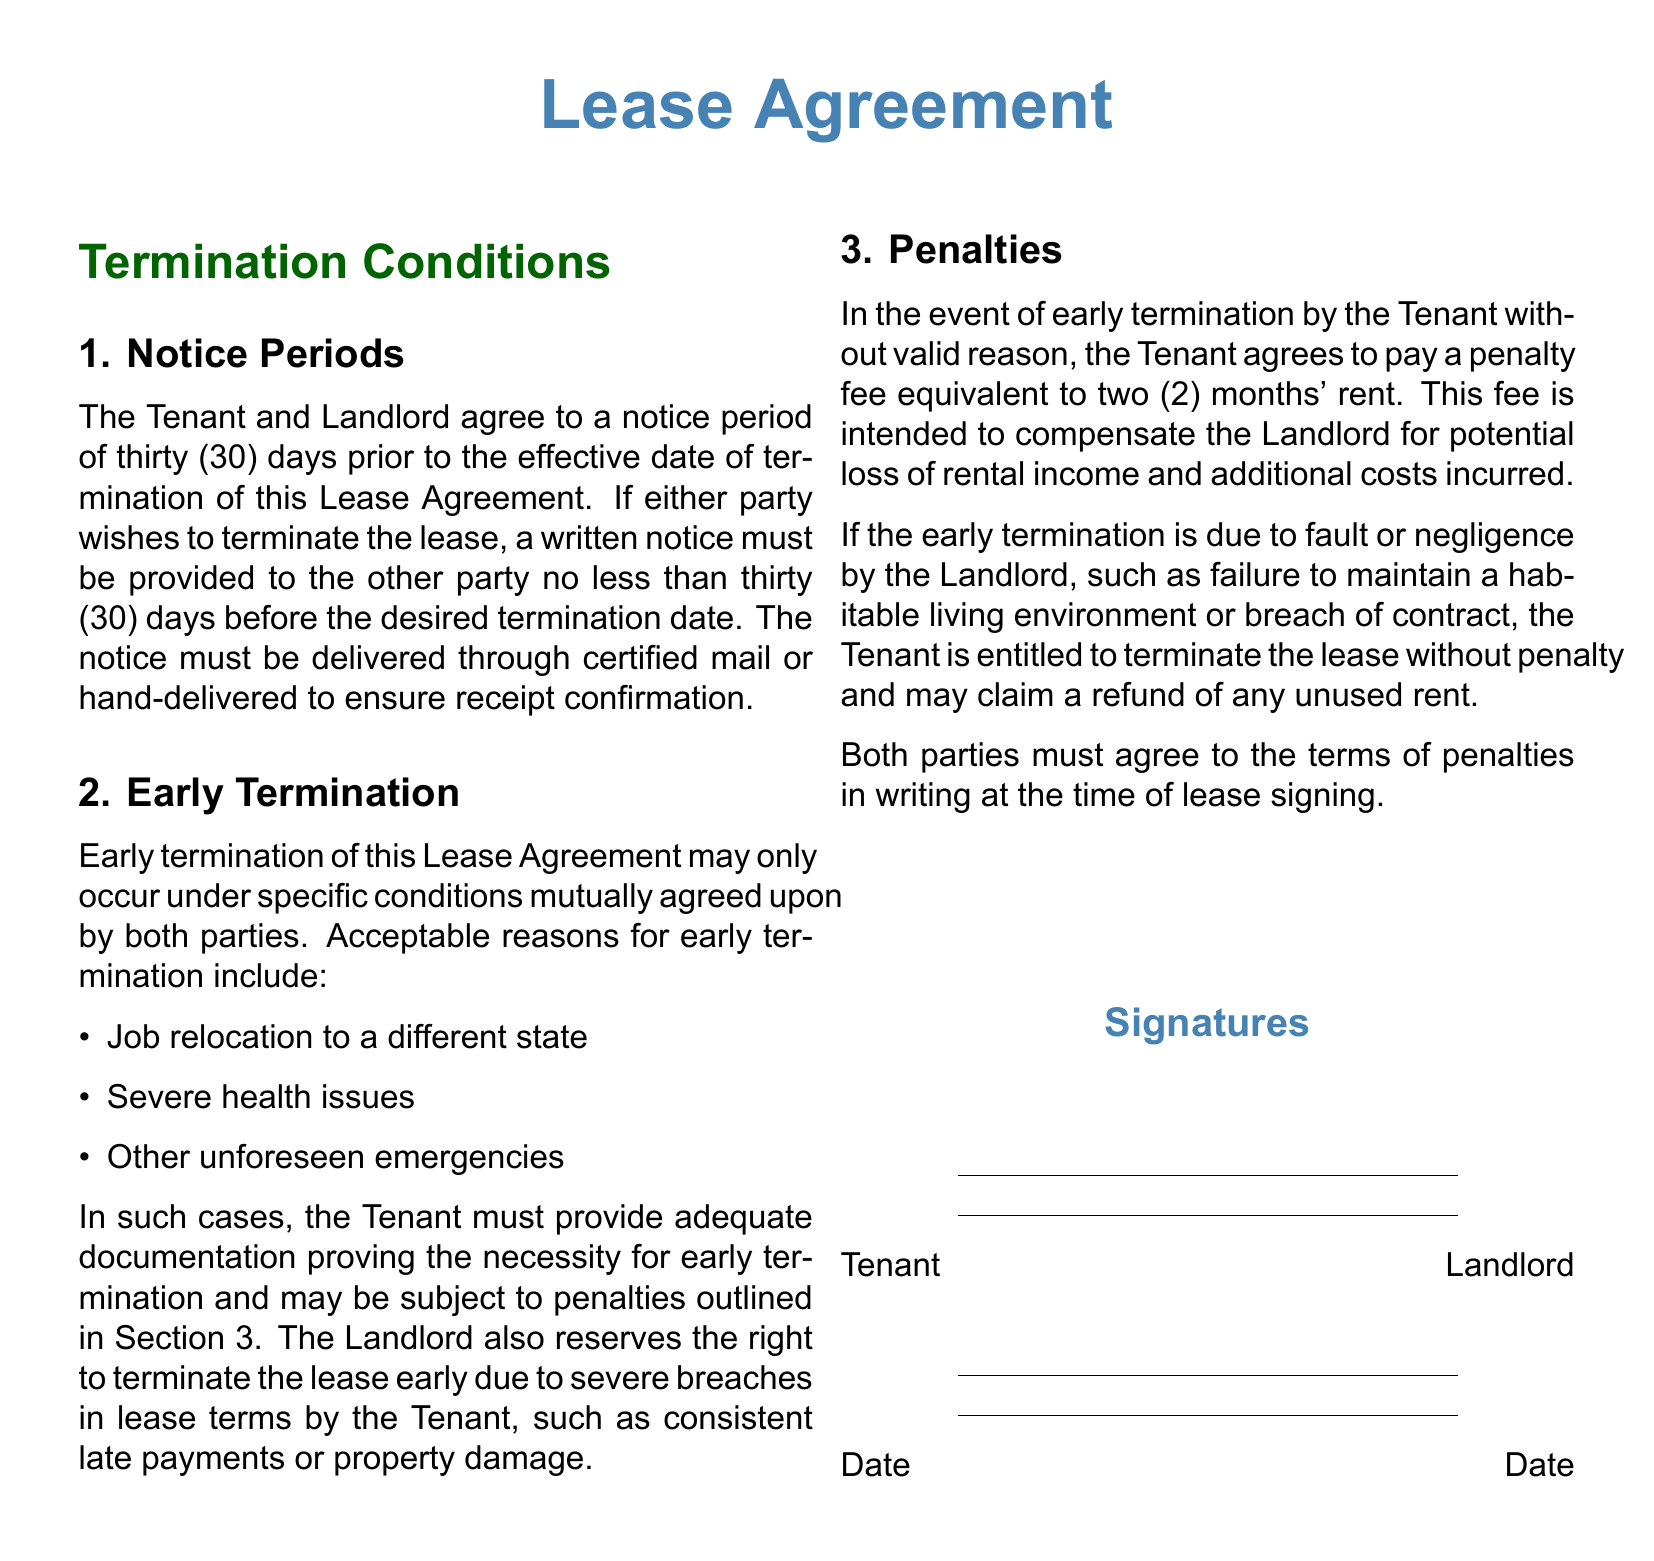What is the notice period for termination? The notice period is specified in the document as thirty (30) days.
Answer: thirty (30) days What should be included in the notice of termination? The document states that a written notice must be provided, indicating the desired termination date.
Answer: written notice What are acceptable reasons for early termination? The document lists job relocation, severe health issues, and unforeseen emergencies as acceptable reasons.
Answer: job relocation, severe health issues, unforeseen emergencies What penalty does the Tenant face for early termination without valid reason? The penalty for early termination without valid reason is specified as two (2) months' rent in the document.
Answer: two (2) months' rent If the Landlord is at fault, what does the Tenant receive upon early termination? If the Landlord is at fault, the Tenant is entitled to a refund of any unused rent.
Answer: refund of unused rent How must the notice of termination be delivered? The document specifies that the notice must be delivered through certified mail or hand-delivered.
Answer: certified mail or hand-delivered What condition allows the Landlord to terminate the lease early? The Landlord can terminate the lease early due to severe breaches in lease terms by the Tenant.
Answer: severe breaches in lease terms What type of document is this? The document is a legal agreement governing the lease between tenant and landlord.
Answer: Lease Agreement 